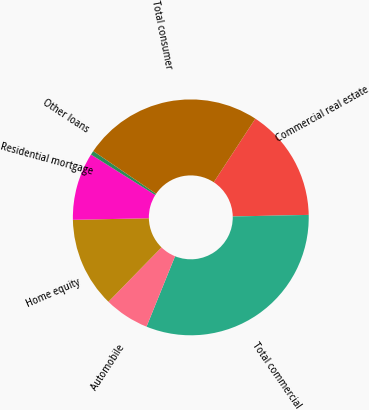<chart> <loc_0><loc_0><loc_500><loc_500><pie_chart><fcel>Commercial real estate<fcel>Total commercial<fcel>Automobile<fcel>Home equity<fcel>Residential mortgage<fcel>Other loans<fcel>Total consumer<nl><fcel>15.45%<fcel>31.46%<fcel>6.18%<fcel>12.36%<fcel>9.27%<fcel>0.56%<fcel>24.72%<nl></chart> 